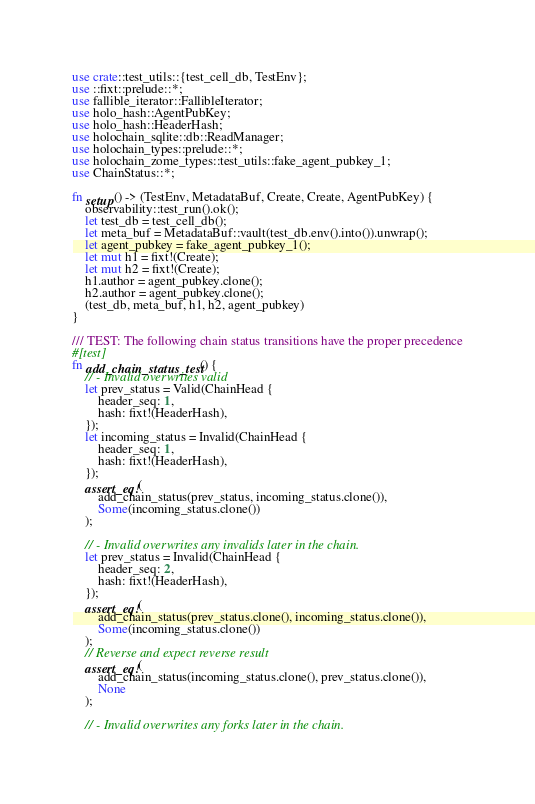Convert code to text. <code><loc_0><loc_0><loc_500><loc_500><_Rust_>use crate::test_utils::{test_cell_db, TestEnv};
use ::fixt::prelude::*;
use fallible_iterator::FallibleIterator;
use holo_hash::AgentPubKey;
use holo_hash::HeaderHash;
use holochain_sqlite::db::ReadManager;
use holochain_types::prelude::*;
use holochain_zome_types::test_utils::fake_agent_pubkey_1;
use ChainStatus::*;

fn setup() -> (TestEnv, MetadataBuf, Create, Create, AgentPubKey) {
    observability::test_run().ok();
    let test_db = test_cell_db();
    let meta_buf = MetadataBuf::vault(test_db.env().into()).unwrap();
    let agent_pubkey = fake_agent_pubkey_1();
    let mut h1 = fixt!(Create);
    let mut h2 = fixt!(Create);
    h1.author = agent_pubkey.clone();
    h2.author = agent_pubkey.clone();
    (test_db, meta_buf, h1, h2, agent_pubkey)
}

/// TEST: The following chain status transitions have the proper precedence
#[test]
fn add_chain_status_test() {
    // - Invalid overwrites valid
    let prev_status = Valid(ChainHead {
        header_seq: 1,
        hash: fixt!(HeaderHash),
    });
    let incoming_status = Invalid(ChainHead {
        header_seq: 1,
        hash: fixt!(HeaderHash),
    });
    assert_eq!(
        add_chain_status(prev_status, incoming_status.clone()),
        Some(incoming_status.clone())
    );

    // - Invalid overwrites any invalids later in the chain.
    let prev_status = Invalid(ChainHead {
        header_seq: 2,
        hash: fixt!(HeaderHash),
    });
    assert_eq!(
        add_chain_status(prev_status.clone(), incoming_status.clone()),
        Some(incoming_status.clone())
    );
    // Reverse and expect reverse result
    assert_eq!(
        add_chain_status(incoming_status.clone(), prev_status.clone()),
        None
    );

    // - Invalid overwrites any forks later in the chain.</code> 